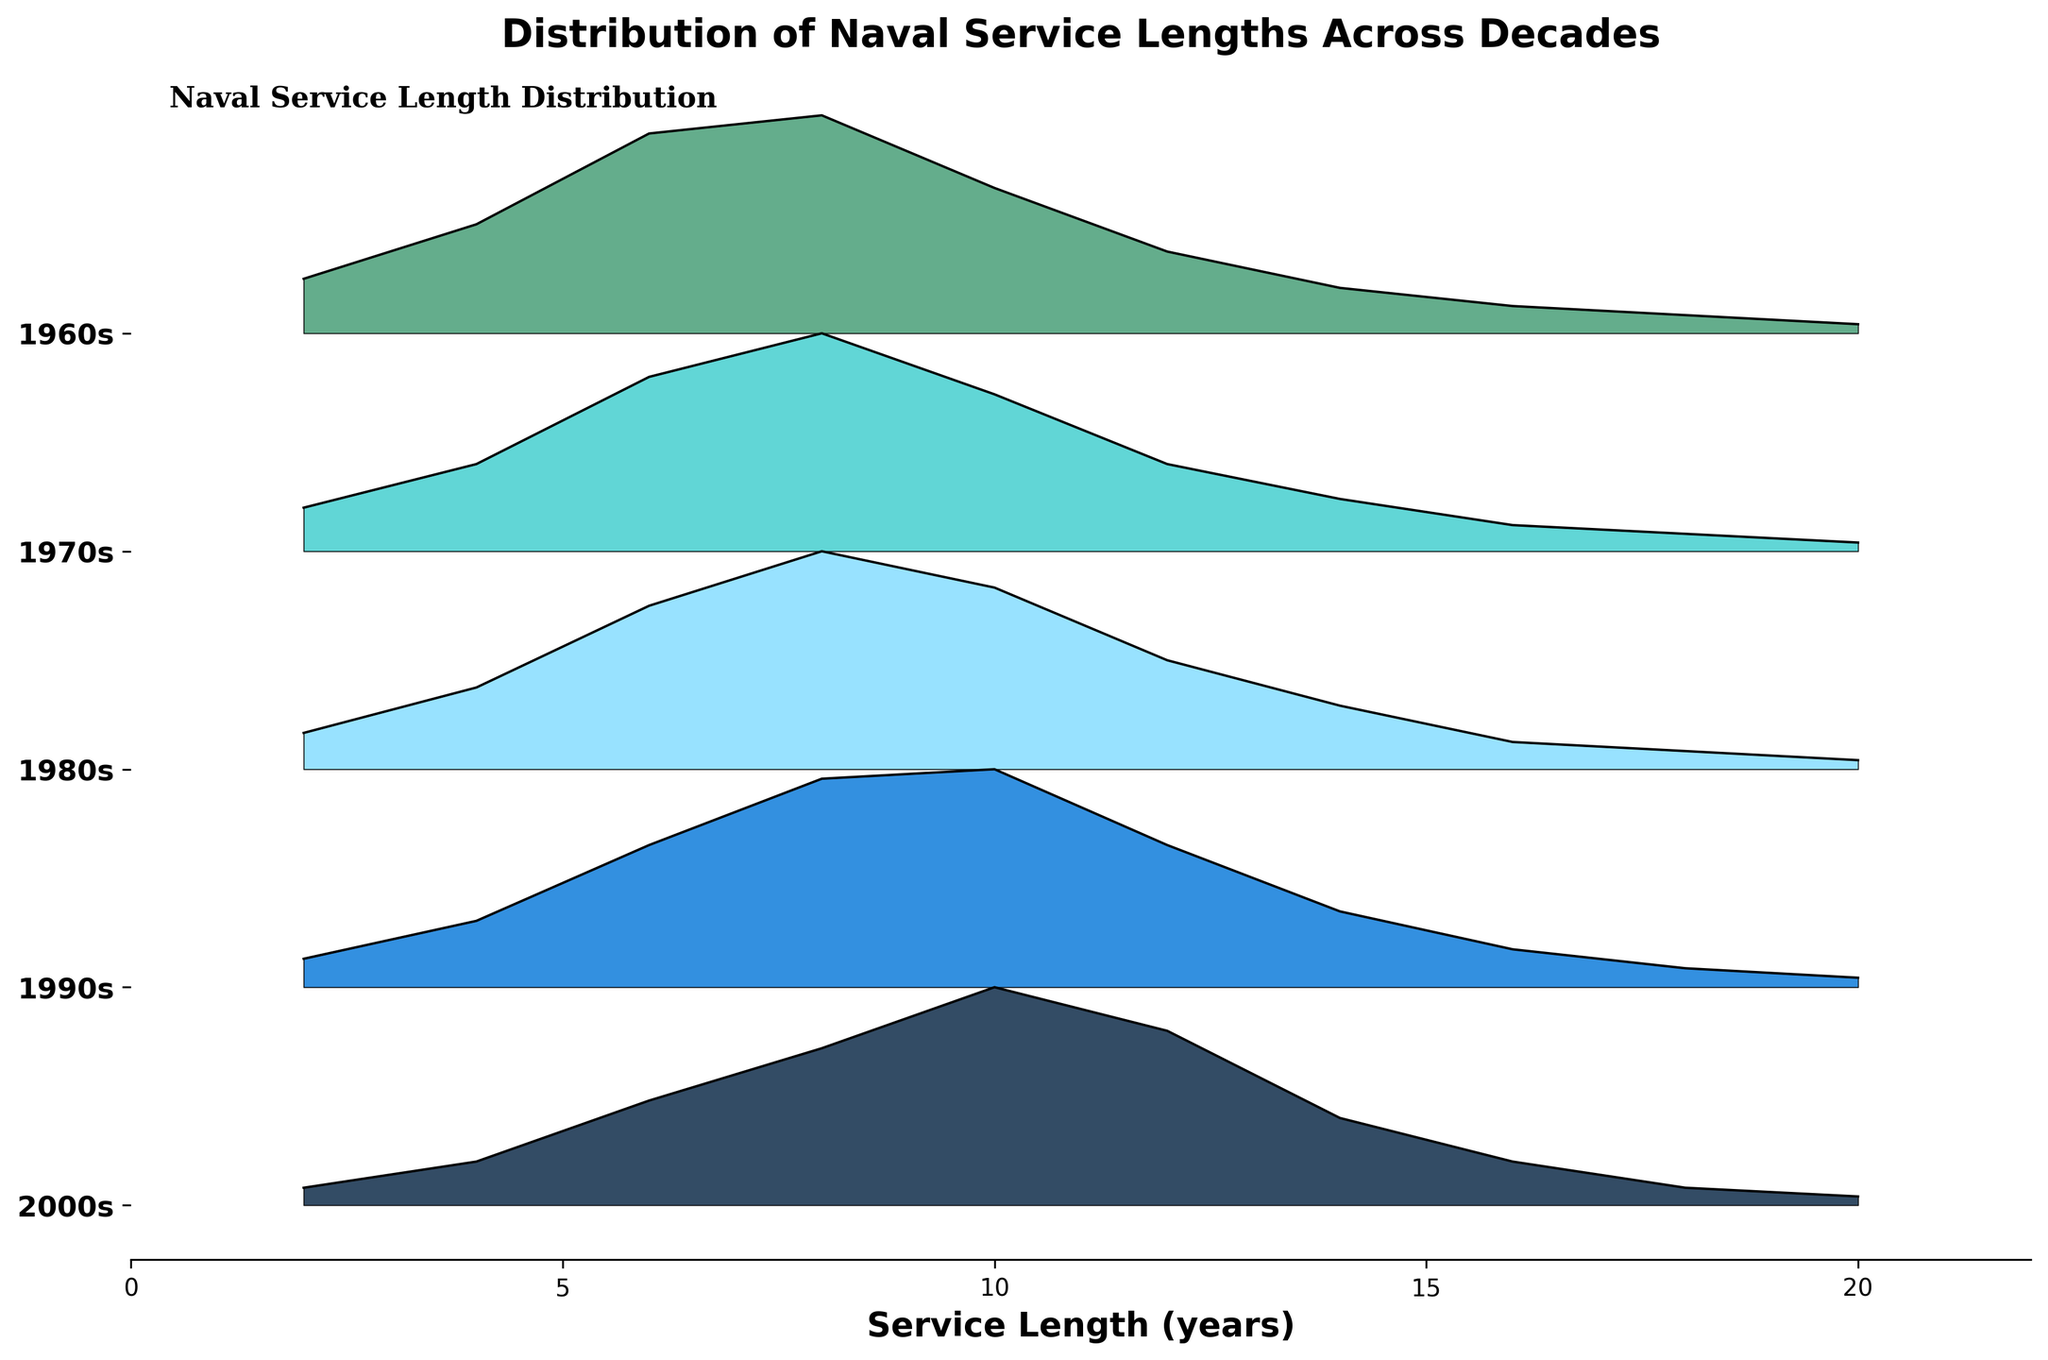What is the title of the plot? The title of the plot is located at the top of the figure and usually describes the main purpose or subject.
Answer: Distribution of Naval Service Lengths Across Decades Which decade shows the highest density in service lengths of 8 years? By observing the plot for each decade, note the heights of the curves at the service length of 8 years. The 1990s decade has the highest peak at this service length.
Answer: 1990s Which decades have the highest peak at a service length of 10 years? By comparing the height of the curves at a service length of 10 years across the decades, note that both the 1960s and 1970s have significant peaks, but the 1960s is slightly higher.
Answer: 1960s What is the trend in the density of service lengths of 2 years across the decades from the 1960s to the 2000s? Observe the density values for the 2-year service length in each decade. The density appears to increase consistently from the 1960s to the 2000s.
Answer: Increasing trend How do the general shapes of the density distributions change from the 1960s to the 2000s? Examine the shapes of the ridgelines from the bottom to the top of the plot. As you move from the 1960s up to the 2000s, the peaks become broader, and the distribution becomes more spread out, indicating a wider range of service lengths becoming more common.
Answer: Broader and more spread out Which decade has the broadest distribution of service lengths? Evaluate the spread of the curves for each decade. The 2000s have the broadest distribution, indicating a wider range of service lengths served.
Answer: 2000s How does the density at a service length of 6 years compare between the decades? By observing the height of the curves at the 6-year service length across the decades, notice that each decade maintains a relatively similar peak height, but it gradually increases from the 1960s to the 1990s before slightly decreasing in the 2000s.
Answer: Slightly increases until 1990s, then decreases Which decade has the lowest density at a service length of 20 years? Check the height of the ridgeline curves at the 20-year service length for each decade. All decades display low densities, but the lowest density is observed in the 1970s.
Answer: 1970s 